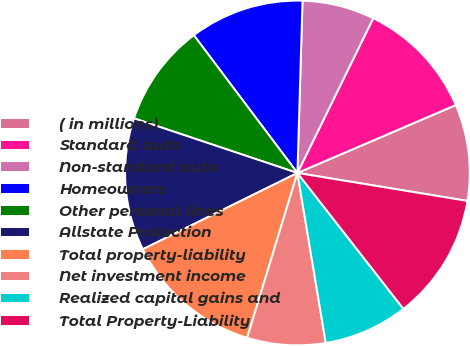Convert chart. <chart><loc_0><loc_0><loc_500><loc_500><pie_chart><fcel>( in millions)<fcel>Standard auto<fcel>Non-standard auto<fcel>Homeowners<fcel>Other personal lines<fcel>Allstate Protection<fcel>Total property-liability<fcel>Net investment income<fcel>Realized capital gains and<fcel>Total Property-Liability<nl><fcel>9.04%<fcel>11.3%<fcel>6.78%<fcel>10.73%<fcel>9.6%<fcel>12.43%<fcel>12.99%<fcel>7.34%<fcel>7.91%<fcel>11.86%<nl></chart> 